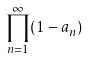Convert formula to latex. <formula><loc_0><loc_0><loc_500><loc_500>\prod _ { n = 1 } ^ { \infty } ( 1 - a _ { n } )</formula> 